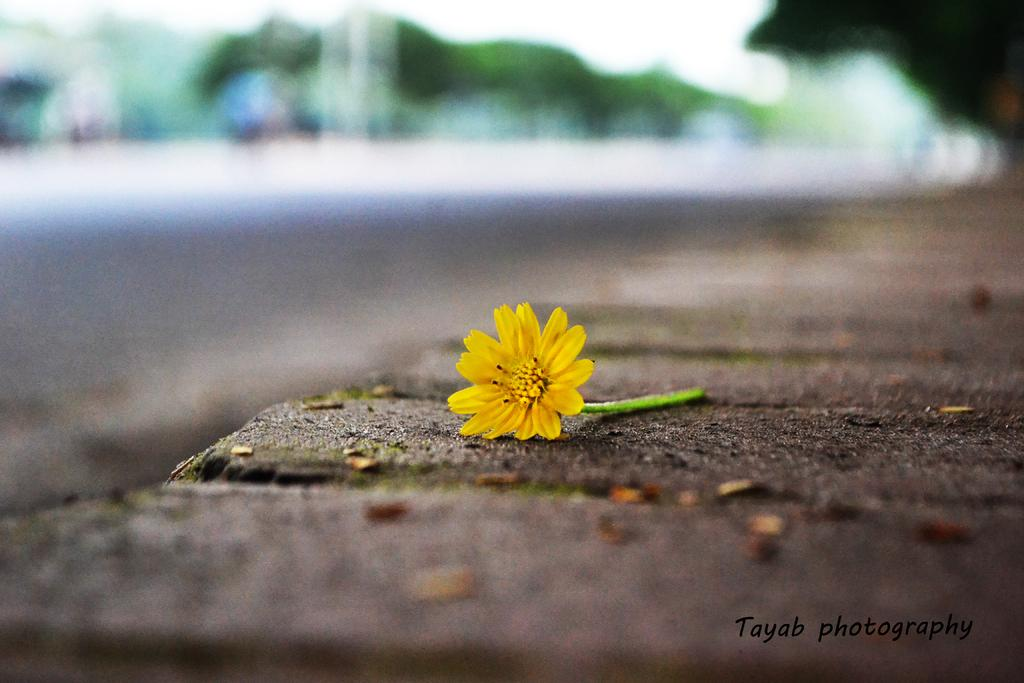What is the main subject of the image? There is a flower in the image. Where is the flower located? The flower is on the ground. What color is the flower? The flower is yellow in color. Can you describe the background of the image? The background of the image is blurred. What type of thunder can be heard in the background of the image? There is no thunder present in the image, as it is a still image of a flower on the ground. 